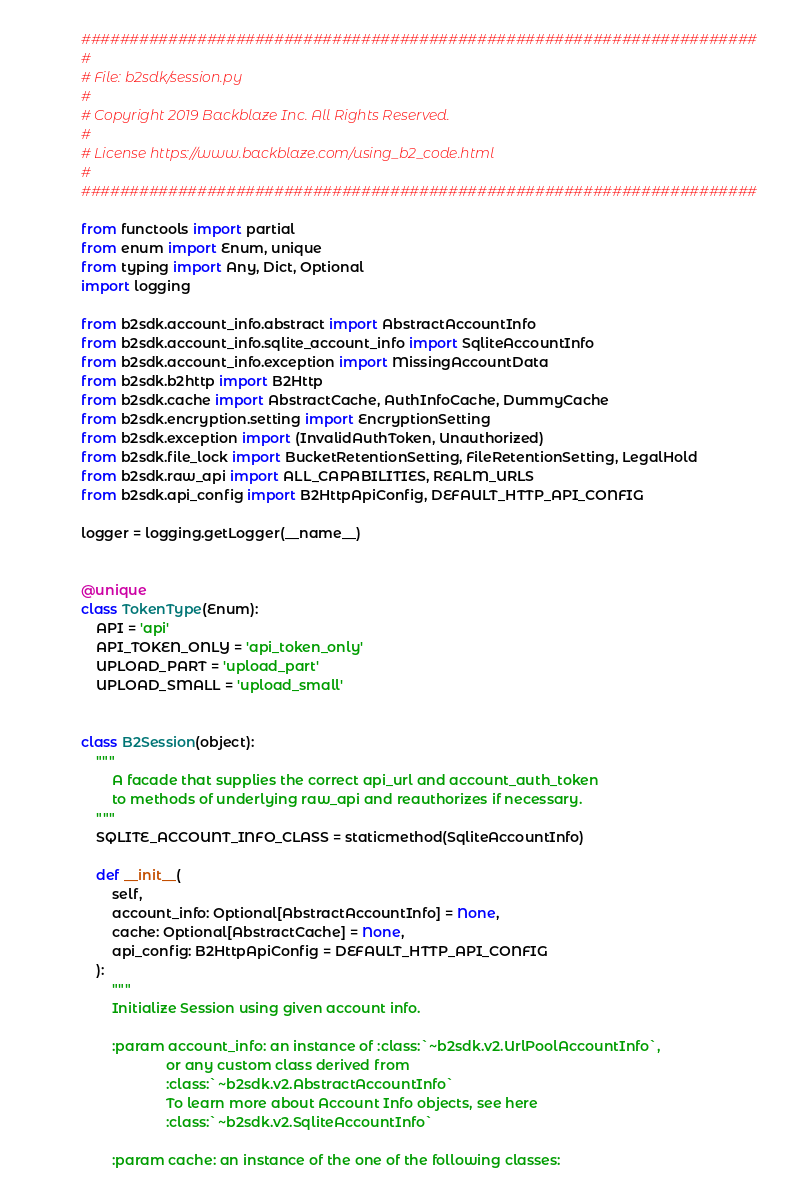Convert code to text. <code><loc_0><loc_0><loc_500><loc_500><_Python_>######################################################################
#
# File: b2sdk/session.py
#
# Copyright 2019 Backblaze Inc. All Rights Reserved.
#
# License https://www.backblaze.com/using_b2_code.html
#
######################################################################

from functools import partial
from enum import Enum, unique
from typing import Any, Dict, Optional
import logging

from b2sdk.account_info.abstract import AbstractAccountInfo
from b2sdk.account_info.sqlite_account_info import SqliteAccountInfo
from b2sdk.account_info.exception import MissingAccountData
from b2sdk.b2http import B2Http
from b2sdk.cache import AbstractCache, AuthInfoCache, DummyCache
from b2sdk.encryption.setting import EncryptionSetting
from b2sdk.exception import (InvalidAuthToken, Unauthorized)
from b2sdk.file_lock import BucketRetentionSetting, FileRetentionSetting, LegalHold
from b2sdk.raw_api import ALL_CAPABILITIES, REALM_URLS
from b2sdk.api_config import B2HttpApiConfig, DEFAULT_HTTP_API_CONFIG

logger = logging.getLogger(__name__)


@unique
class TokenType(Enum):
    API = 'api'
    API_TOKEN_ONLY = 'api_token_only'
    UPLOAD_PART = 'upload_part'
    UPLOAD_SMALL = 'upload_small'


class B2Session(object):
    """
        A facade that supplies the correct api_url and account_auth_token
        to methods of underlying raw_api and reauthorizes if necessary.
    """
    SQLITE_ACCOUNT_INFO_CLASS = staticmethod(SqliteAccountInfo)

    def __init__(
        self,
        account_info: Optional[AbstractAccountInfo] = None,
        cache: Optional[AbstractCache] = None,
        api_config: B2HttpApiConfig = DEFAULT_HTTP_API_CONFIG
    ):
        """
        Initialize Session using given account info.

        :param account_info: an instance of :class:`~b2sdk.v2.UrlPoolAccountInfo`,
                      or any custom class derived from
                      :class:`~b2sdk.v2.AbstractAccountInfo`
                      To learn more about Account Info objects, see here
                      :class:`~b2sdk.v2.SqliteAccountInfo`

        :param cache: an instance of the one of the following classes:</code> 